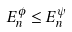Convert formula to latex. <formula><loc_0><loc_0><loc_500><loc_500>E _ { n } ^ { \phi } \leq E _ { n } ^ { \psi }</formula> 